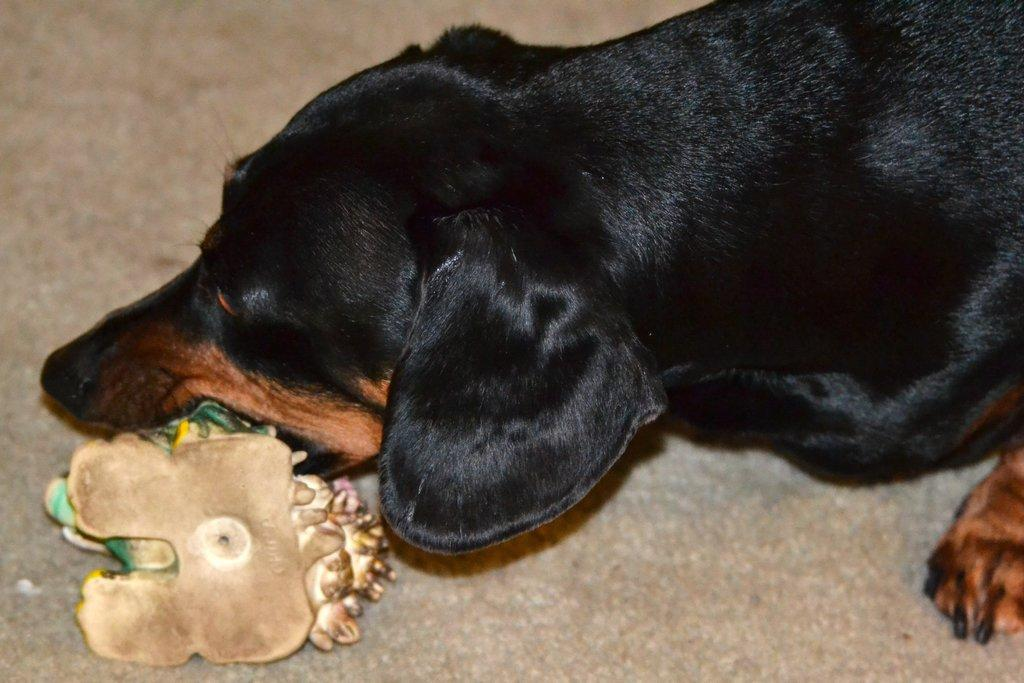What animal is present in the image? There is a dog in the image. What is the dog doing in the image? The dog is baiting an object on the ground. Who is the servant attending to in the image? There is no servant present in the image. What crime is being committed in the image? There is no crime being committed in the image; it features a dog baiting an object on the ground. Is there a plane visible in the image? There is no plane present in the image. 